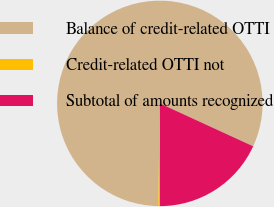Convert chart to OTSL. <chart><loc_0><loc_0><loc_500><loc_500><pie_chart><fcel>Balance of credit-related OTTI<fcel>Credit-related OTTI not<fcel>Subtotal of amounts recognized<nl><fcel>81.61%<fcel>0.25%<fcel>18.14%<nl></chart> 